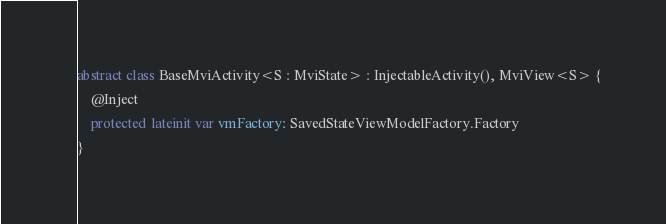<code> <loc_0><loc_0><loc_500><loc_500><_Kotlin_>abstract class BaseMviActivity<S : MviState> : InjectableActivity(), MviView<S> {
    @Inject
    protected lateinit var vmFactory: SavedStateViewModelFactory.Factory
}
</code> 